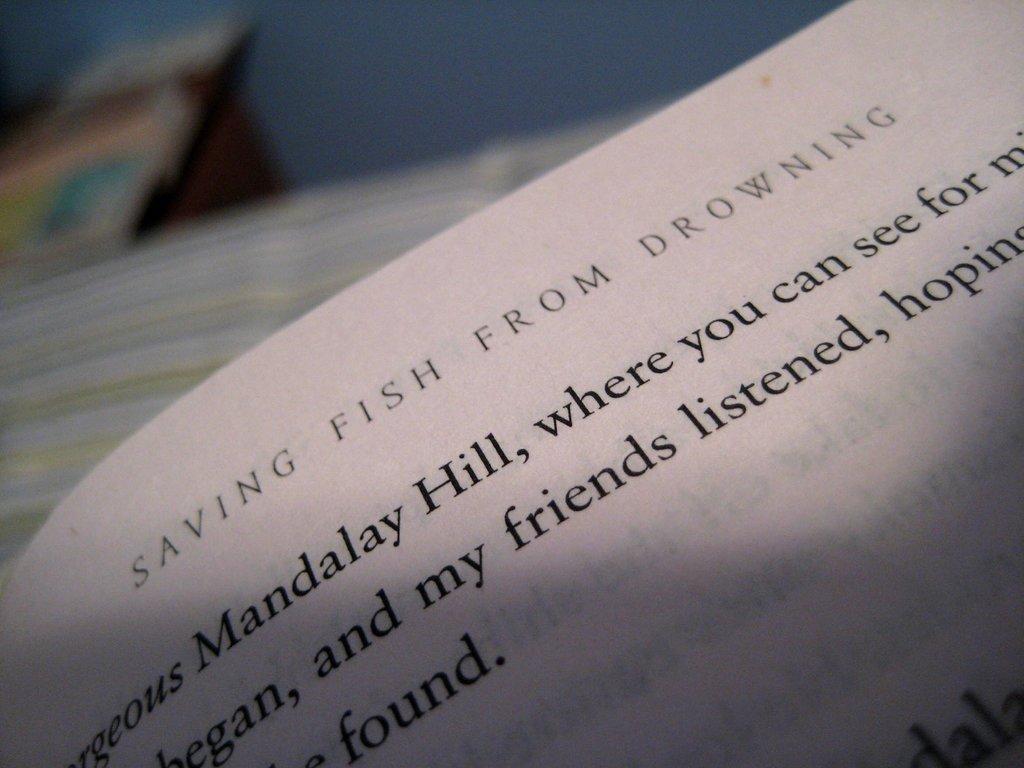What is the title of the book?
Offer a very short reply. Saving fish from drowning. Which hill is referenced in the book?
Offer a terse response. Mandalay. 